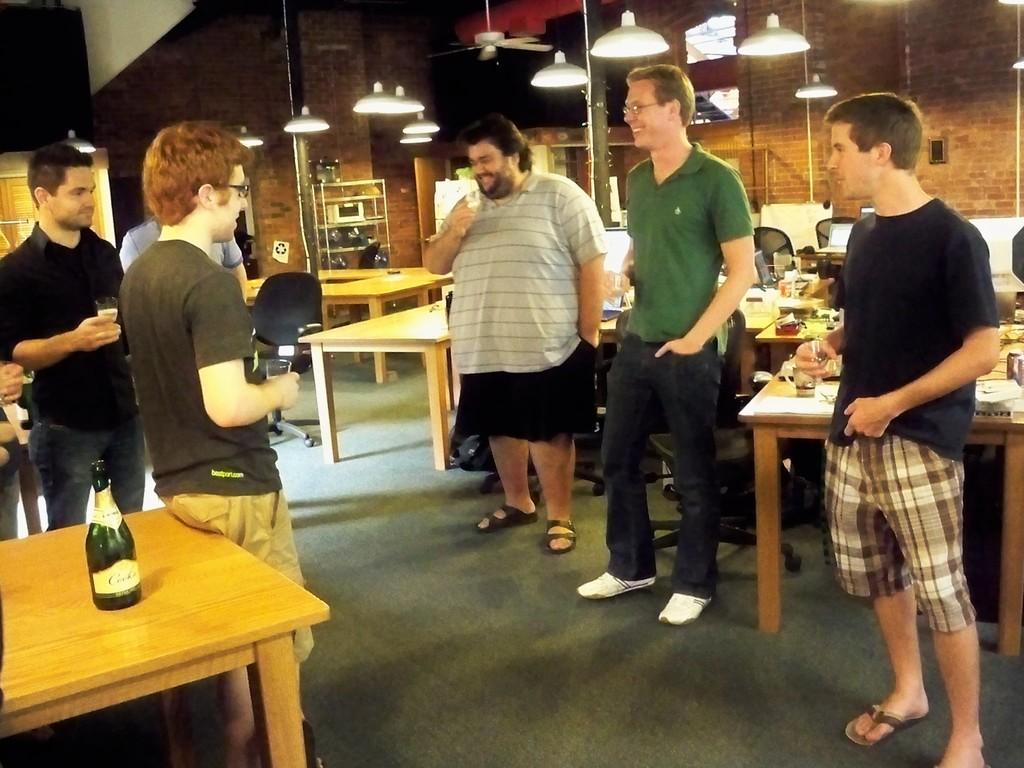Could you give a brief overview of what you see in this image? In this picture we can see men standing near to the table and smiling. On the table we can see bottles, glasses. This is a floor. At the top we can see lights. 